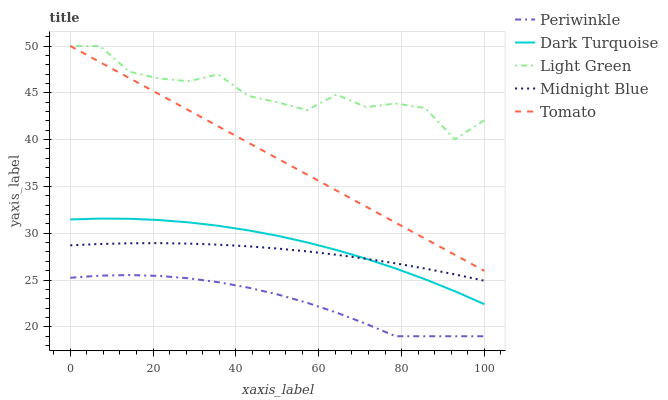Does Periwinkle have the minimum area under the curve?
Answer yes or no. Yes. Does Light Green have the maximum area under the curve?
Answer yes or no. Yes. Does Dark Turquoise have the minimum area under the curve?
Answer yes or no. No. Does Dark Turquoise have the maximum area under the curve?
Answer yes or no. No. Is Tomato the smoothest?
Answer yes or no. Yes. Is Light Green the roughest?
Answer yes or no. Yes. Is Dark Turquoise the smoothest?
Answer yes or no. No. Is Dark Turquoise the roughest?
Answer yes or no. No. Does Periwinkle have the lowest value?
Answer yes or no. Yes. Does Dark Turquoise have the lowest value?
Answer yes or no. No. Does Light Green have the highest value?
Answer yes or no. Yes. Does Dark Turquoise have the highest value?
Answer yes or no. No. Is Dark Turquoise less than Light Green?
Answer yes or no. Yes. Is Tomato greater than Midnight Blue?
Answer yes or no. Yes. Does Dark Turquoise intersect Midnight Blue?
Answer yes or no. Yes. Is Dark Turquoise less than Midnight Blue?
Answer yes or no. No. Is Dark Turquoise greater than Midnight Blue?
Answer yes or no. No. Does Dark Turquoise intersect Light Green?
Answer yes or no. No. 